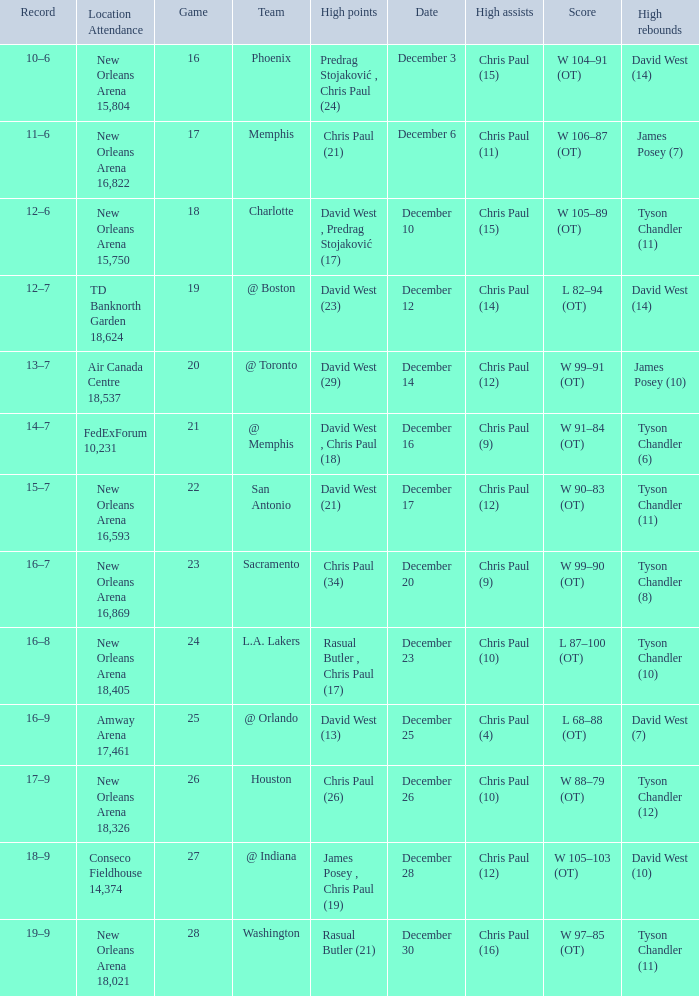What is Score, when Team is "@ Memphis"? W 91–84 (OT). 